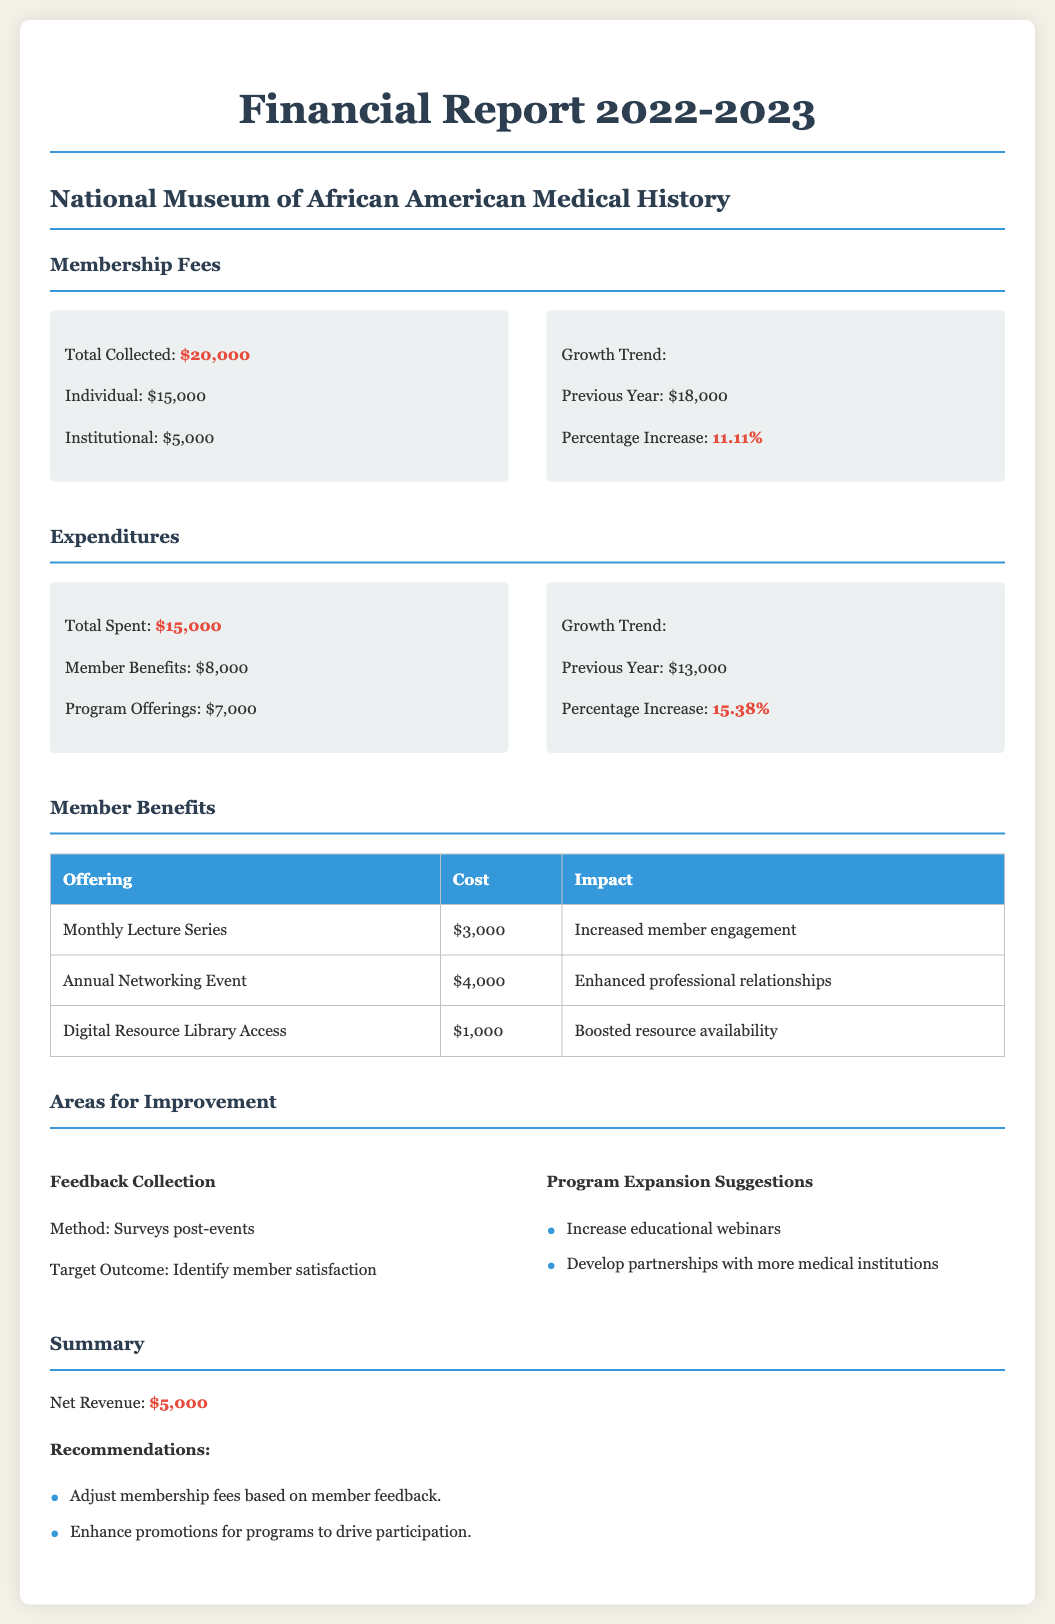what is the total collected membership fees? The total collected membership fees can be found in the Membership Fees section of the document, stating $20,000.
Answer: $20,000 what was the percentage increase in membership fees? The percentage increase is mentioned in the Membership Fees section, indicating an increase of 11.11%.
Answer: 11.11% how much was spent on member benefits? The document specifies that $8,000 was spent on member benefits in the Expenditures section.
Answer: $8,000 what is the total expenditure for program offerings? The Expenditures section states that the total spent on program offerings is $7,000.
Answer: $7,000 what is the net revenue for the year? The summary section mentions the net revenue amount, which is $5,000.
Answer: $5,000 how much was allocated for the Monthly Lecture Series? The Member Benefits table lists the cost for the Monthly Lecture Series as $3,000.
Answer: $3,000 what is one area for improvement suggested in the report? The report mentions that one area for improvement is increasing educational webinars.
Answer: Increase educational webinars what method is suggested for collecting member feedback? The report states that surveys post-events should be used as a method for collecting feedback.
Answer: Surveys post-events what were the previous year expenditures? The previous year expenditures are reported as $13,000 in the Expenditures section of the document.
Answer: $13,000 what is one recommendation provided in the summary? One recommendation given in the summary is to enhance promotions for programs to drive participation.
Answer: Enhance promotions for programs to drive participation 